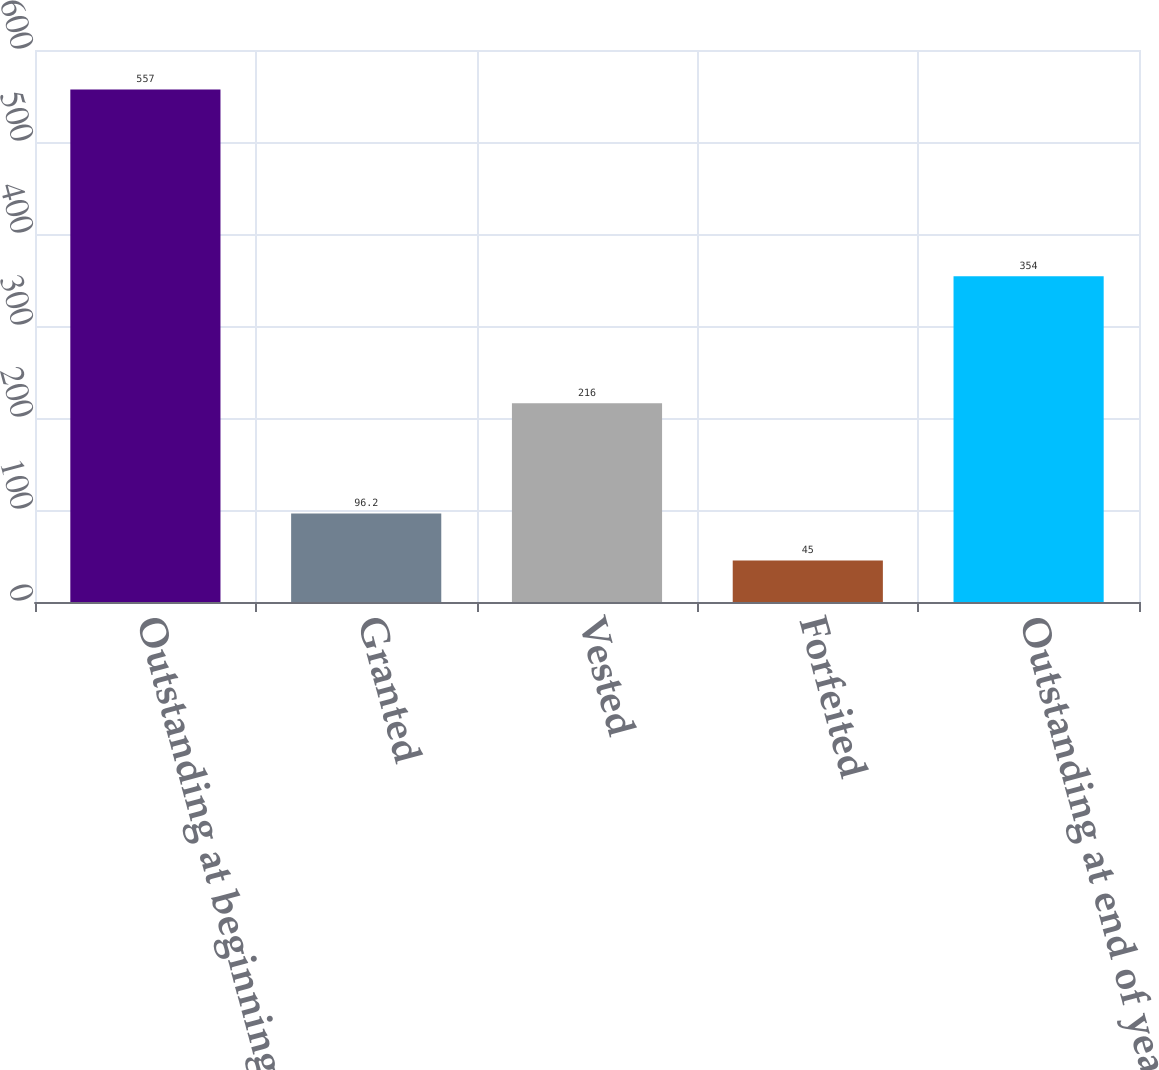<chart> <loc_0><loc_0><loc_500><loc_500><bar_chart><fcel>Outstanding at beginning of<fcel>Granted<fcel>Vested<fcel>Forfeited<fcel>Outstanding at end of year<nl><fcel>557<fcel>96.2<fcel>216<fcel>45<fcel>354<nl></chart> 